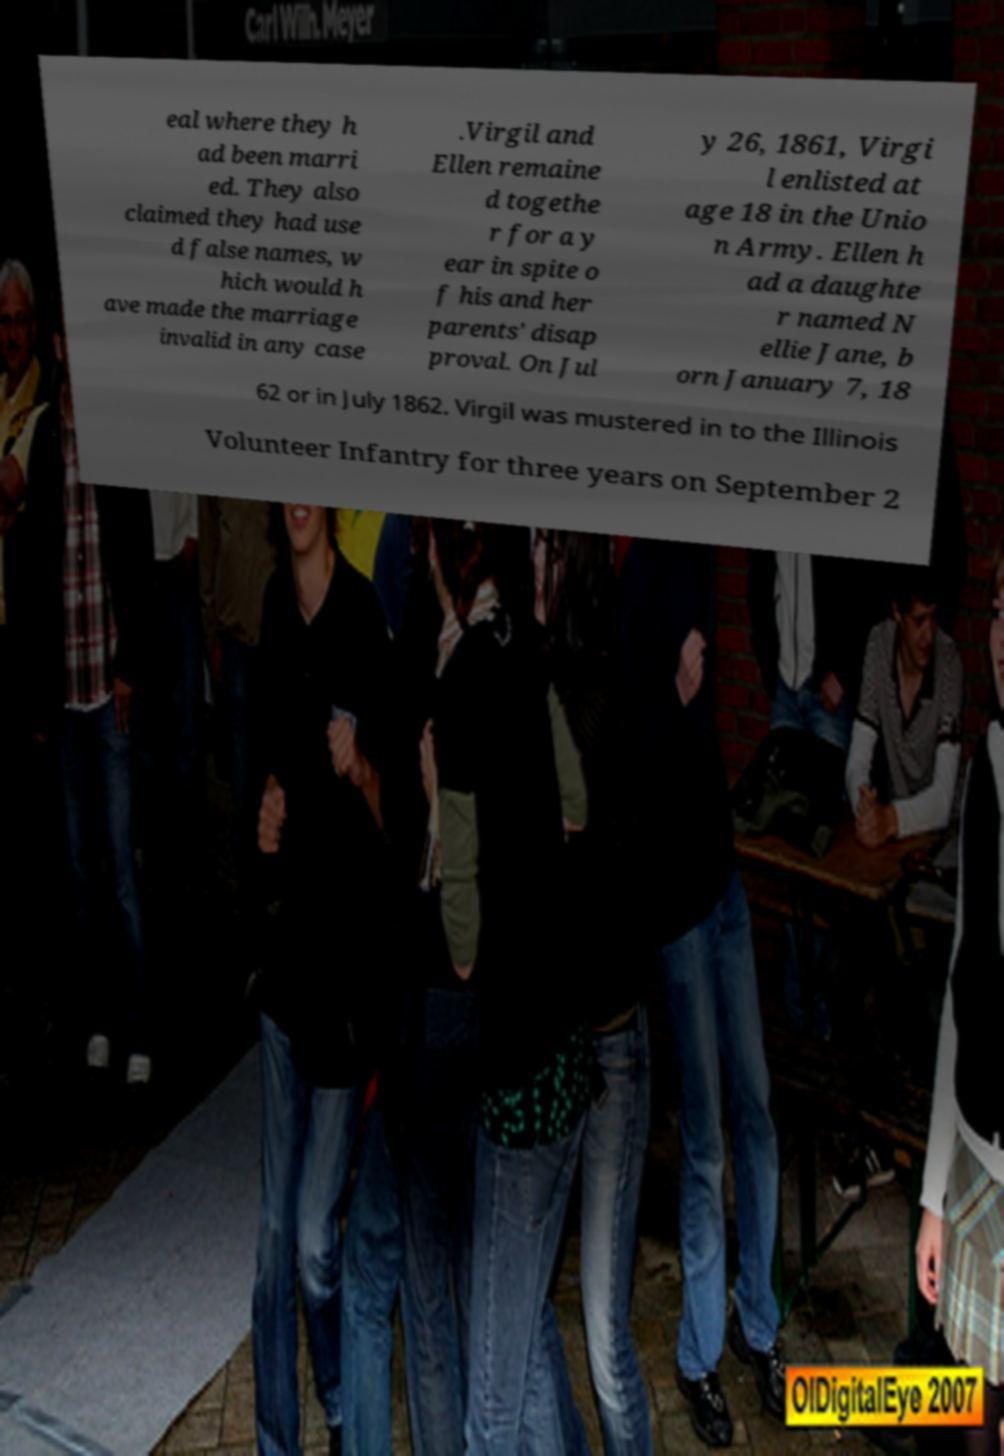Can you read and provide the text displayed in the image?This photo seems to have some interesting text. Can you extract and type it out for me? eal where they h ad been marri ed. They also claimed they had use d false names, w hich would h ave made the marriage invalid in any case .Virgil and Ellen remaine d togethe r for a y ear in spite o f his and her parents' disap proval. On Jul y 26, 1861, Virgi l enlisted at age 18 in the Unio n Army. Ellen h ad a daughte r named N ellie Jane, b orn January 7, 18 62 or in July 1862. Virgil was mustered in to the Illinois Volunteer Infantry for three years on September 2 